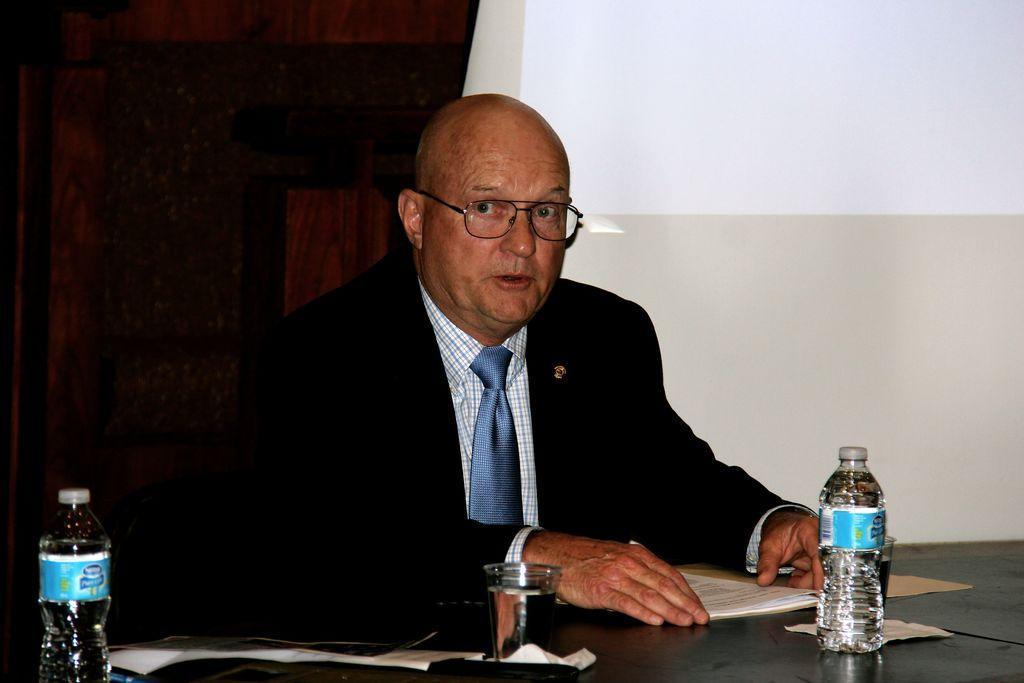Describe this image in one or two sentences. In this picture we can see man wore blazer, tie, spectacle and looking at some where and in front of him there is table and on table we can see glass, bottle, papers and in background we can see curtains, wall. 